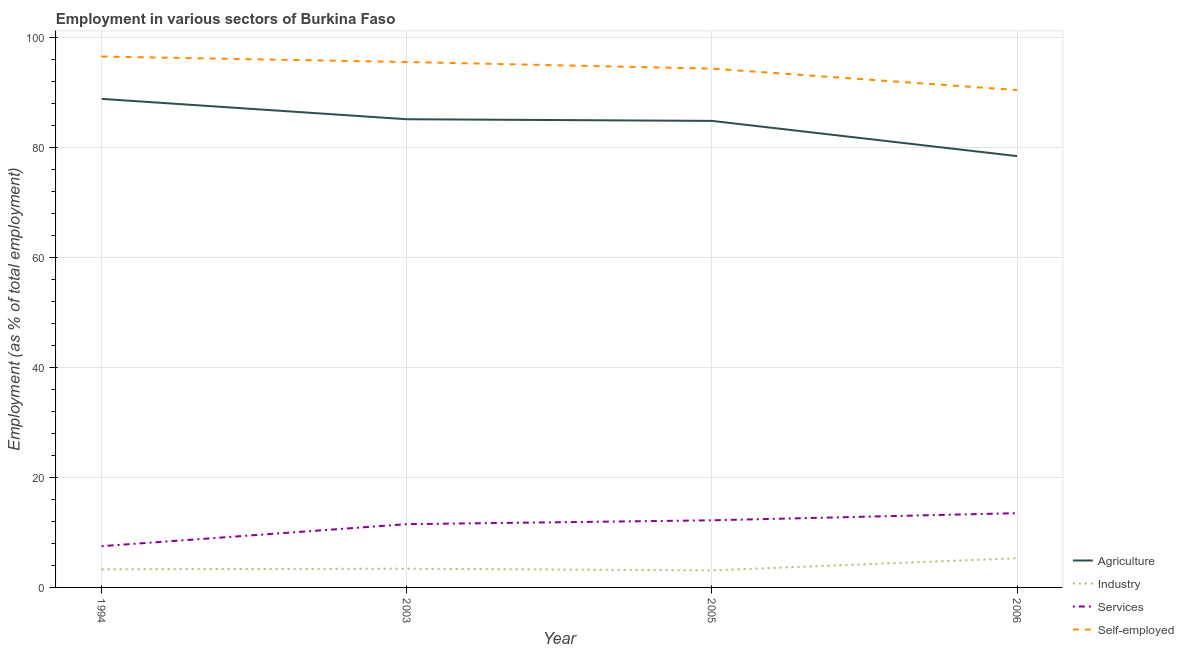Is the number of lines equal to the number of legend labels?
Your answer should be compact. Yes. What is the percentage of workers in services in 2005?
Provide a short and direct response. 12.2. Across all years, what is the maximum percentage of workers in agriculture?
Ensure brevity in your answer.  88.8. Across all years, what is the minimum percentage of self employed workers?
Provide a succinct answer. 90.4. In which year was the percentage of workers in services minimum?
Provide a succinct answer. 1994. What is the total percentage of workers in services in the graph?
Offer a very short reply. 44.7. What is the difference between the percentage of workers in industry in 2006 and the percentage of workers in services in 2005?
Provide a short and direct response. -6.9. What is the average percentage of self employed workers per year?
Give a very brief answer. 94.18. In the year 2003, what is the difference between the percentage of workers in services and percentage of workers in agriculture?
Provide a short and direct response. -73.6. In how many years, is the percentage of self employed workers greater than 64 %?
Make the answer very short. 4. What is the ratio of the percentage of workers in agriculture in 2005 to that in 2006?
Make the answer very short. 1.08. Is the difference between the percentage of workers in industry in 2005 and 2006 greater than the difference between the percentage of self employed workers in 2005 and 2006?
Your response must be concise. No. What is the difference between the highest and the second highest percentage of workers in services?
Give a very brief answer. 1.3. What is the difference between the highest and the lowest percentage of workers in industry?
Your response must be concise. 2.2. Does the percentage of workers in services monotonically increase over the years?
Your response must be concise. Yes. Is the percentage of workers in industry strictly less than the percentage of workers in services over the years?
Your response must be concise. Yes. How many years are there in the graph?
Your answer should be very brief. 4. Are the values on the major ticks of Y-axis written in scientific E-notation?
Provide a succinct answer. No. Does the graph contain any zero values?
Provide a short and direct response. No. How many legend labels are there?
Your response must be concise. 4. What is the title of the graph?
Your answer should be compact. Employment in various sectors of Burkina Faso. What is the label or title of the Y-axis?
Offer a very short reply. Employment (as % of total employment). What is the Employment (as % of total employment) in Agriculture in 1994?
Make the answer very short. 88.8. What is the Employment (as % of total employment) of Industry in 1994?
Your answer should be compact. 3.3. What is the Employment (as % of total employment) in Self-employed in 1994?
Ensure brevity in your answer.  96.5. What is the Employment (as % of total employment) in Agriculture in 2003?
Give a very brief answer. 85.1. What is the Employment (as % of total employment) of Industry in 2003?
Your answer should be compact. 3.4. What is the Employment (as % of total employment) of Services in 2003?
Provide a short and direct response. 11.5. What is the Employment (as % of total employment) of Self-employed in 2003?
Ensure brevity in your answer.  95.5. What is the Employment (as % of total employment) of Agriculture in 2005?
Your answer should be very brief. 84.8. What is the Employment (as % of total employment) of Industry in 2005?
Your answer should be very brief. 3.1. What is the Employment (as % of total employment) of Services in 2005?
Offer a very short reply. 12.2. What is the Employment (as % of total employment) of Self-employed in 2005?
Your answer should be very brief. 94.3. What is the Employment (as % of total employment) in Agriculture in 2006?
Give a very brief answer. 78.4. What is the Employment (as % of total employment) of Industry in 2006?
Give a very brief answer. 5.3. What is the Employment (as % of total employment) in Self-employed in 2006?
Offer a very short reply. 90.4. Across all years, what is the maximum Employment (as % of total employment) in Agriculture?
Make the answer very short. 88.8. Across all years, what is the maximum Employment (as % of total employment) in Industry?
Provide a short and direct response. 5.3. Across all years, what is the maximum Employment (as % of total employment) in Services?
Keep it short and to the point. 13.5. Across all years, what is the maximum Employment (as % of total employment) in Self-employed?
Your response must be concise. 96.5. Across all years, what is the minimum Employment (as % of total employment) of Agriculture?
Offer a very short reply. 78.4. Across all years, what is the minimum Employment (as % of total employment) of Industry?
Make the answer very short. 3.1. Across all years, what is the minimum Employment (as % of total employment) in Self-employed?
Provide a short and direct response. 90.4. What is the total Employment (as % of total employment) of Agriculture in the graph?
Make the answer very short. 337.1. What is the total Employment (as % of total employment) in Industry in the graph?
Offer a very short reply. 15.1. What is the total Employment (as % of total employment) in Services in the graph?
Keep it short and to the point. 44.7. What is the total Employment (as % of total employment) in Self-employed in the graph?
Ensure brevity in your answer.  376.7. What is the difference between the Employment (as % of total employment) in Agriculture in 1994 and that in 2003?
Your answer should be compact. 3.7. What is the difference between the Employment (as % of total employment) of Services in 1994 and that in 2003?
Provide a short and direct response. -4. What is the difference between the Employment (as % of total employment) in Self-employed in 1994 and that in 2003?
Provide a succinct answer. 1. What is the difference between the Employment (as % of total employment) in Agriculture in 1994 and that in 2005?
Your answer should be compact. 4. What is the difference between the Employment (as % of total employment) of Services in 1994 and that in 2005?
Make the answer very short. -4.7. What is the difference between the Employment (as % of total employment) of Services in 1994 and that in 2006?
Offer a terse response. -6. What is the difference between the Employment (as % of total employment) of Self-employed in 1994 and that in 2006?
Your answer should be compact. 6.1. What is the difference between the Employment (as % of total employment) in Services in 2003 and that in 2005?
Provide a short and direct response. -0.7. What is the difference between the Employment (as % of total employment) in Self-employed in 2003 and that in 2005?
Ensure brevity in your answer.  1.2. What is the difference between the Employment (as % of total employment) in Services in 2003 and that in 2006?
Your answer should be very brief. -2. What is the difference between the Employment (as % of total employment) in Agriculture in 2005 and that in 2006?
Offer a terse response. 6.4. What is the difference between the Employment (as % of total employment) of Services in 2005 and that in 2006?
Your answer should be very brief. -1.3. What is the difference between the Employment (as % of total employment) of Self-employed in 2005 and that in 2006?
Your answer should be compact. 3.9. What is the difference between the Employment (as % of total employment) in Agriculture in 1994 and the Employment (as % of total employment) in Industry in 2003?
Your answer should be very brief. 85.4. What is the difference between the Employment (as % of total employment) in Agriculture in 1994 and the Employment (as % of total employment) in Services in 2003?
Offer a very short reply. 77.3. What is the difference between the Employment (as % of total employment) in Industry in 1994 and the Employment (as % of total employment) in Services in 2003?
Provide a short and direct response. -8.2. What is the difference between the Employment (as % of total employment) in Industry in 1994 and the Employment (as % of total employment) in Self-employed in 2003?
Keep it short and to the point. -92.2. What is the difference between the Employment (as % of total employment) of Services in 1994 and the Employment (as % of total employment) of Self-employed in 2003?
Give a very brief answer. -88. What is the difference between the Employment (as % of total employment) in Agriculture in 1994 and the Employment (as % of total employment) in Industry in 2005?
Provide a short and direct response. 85.7. What is the difference between the Employment (as % of total employment) in Agriculture in 1994 and the Employment (as % of total employment) in Services in 2005?
Provide a succinct answer. 76.6. What is the difference between the Employment (as % of total employment) of Agriculture in 1994 and the Employment (as % of total employment) of Self-employed in 2005?
Ensure brevity in your answer.  -5.5. What is the difference between the Employment (as % of total employment) of Industry in 1994 and the Employment (as % of total employment) of Self-employed in 2005?
Your answer should be compact. -91. What is the difference between the Employment (as % of total employment) of Services in 1994 and the Employment (as % of total employment) of Self-employed in 2005?
Your answer should be compact. -86.8. What is the difference between the Employment (as % of total employment) in Agriculture in 1994 and the Employment (as % of total employment) in Industry in 2006?
Offer a terse response. 83.5. What is the difference between the Employment (as % of total employment) of Agriculture in 1994 and the Employment (as % of total employment) of Services in 2006?
Offer a very short reply. 75.3. What is the difference between the Employment (as % of total employment) in Agriculture in 1994 and the Employment (as % of total employment) in Self-employed in 2006?
Your response must be concise. -1.6. What is the difference between the Employment (as % of total employment) of Industry in 1994 and the Employment (as % of total employment) of Services in 2006?
Make the answer very short. -10.2. What is the difference between the Employment (as % of total employment) of Industry in 1994 and the Employment (as % of total employment) of Self-employed in 2006?
Your answer should be very brief. -87.1. What is the difference between the Employment (as % of total employment) in Services in 1994 and the Employment (as % of total employment) in Self-employed in 2006?
Your response must be concise. -82.9. What is the difference between the Employment (as % of total employment) of Agriculture in 2003 and the Employment (as % of total employment) of Services in 2005?
Your answer should be very brief. 72.9. What is the difference between the Employment (as % of total employment) of Agriculture in 2003 and the Employment (as % of total employment) of Self-employed in 2005?
Give a very brief answer. -9.2. What is the difference between the Employment (as % of total employment) in Industry in 2003 and the Employment (as % of total employment) in Services in 2005?
Make the answer very short. -8.8. What is the difference between the Employment (as % of total employment) of Industry in 2003 and the Employment (as % of total employment) of Self-employed in 2005?
Provide a short and direct response. -90.9. What is the difference between the Employment (as % of total employment) in Services in 2003 and the Employment (as % of total employment) in Self-employed in 2005?
Make the answer very short. -82.8. What is the difference between the Employment (as % of total employment) in Agriculture in 2003 and the Employment (as % of total employment) in Industry in 2006?
Offer a terse response. 79.8. What is the difference between the Employment (as % of total employment) of Agriculture in 2003 and the Employment (as % of total employment) of Services in 2006?
Your answer should be compact. 71.6. What is the difference between the Employment (as % of total employment) in Agriculture in 2003 and the Employment (as % of total employment) in Self-employed in 2006?
Give a very brief answer. -5.3. What is the difference between the Employment (as % of total employment) of Industry in 2003 and the Employment (as % of total employment) of Services in 2006?
Your answer should be compact. -10.1. What is the difference between the Employment (as % of total employment) in Industry in 2003 and the Employment (as % of total employment) in Self-employed in 2006?
Provide a short and direct response. -87. What is the difference between the Employment (as % of total employment) in Services in 2003 and the Employment (as % of total employment) in Self-employed in 2006?
Ensure brevity in your answer.  -78.9. What is the difference between the Employment (as % of total employment) in Agriculture in 2005 and the Employment (as % of total employment) in Industry in 2006?
Give a very brief answer. 79.5. What is the difference between the Employment (as % of total employment) of Agriculture in 2005 and the Employment (as % of total employment) of Services in 2006?
Your response must be concise. 71.3. What is the difference between the Employment (as % of total employment) in Agriculture in 2005 and the Employment (as % of total employment) in Self-employed in 2006?
Give a very brief answer. -5.6. What is the difference between the Employment (as % of total employment) of Industry in 2005 and the Employment (as % of total employment) of Services in 2006?
Keep it short and to the point. -10.4. What is the difference between the Employment (as % of total employment) of Industry in 2005 and the Employment (as % of total employment) of Self-employed in 2006?
Give a very brief answer. -87.3. What is the difference between the Employment (as % of total employment) in Services in 2005 and the Employment (as % of total employment) in Self-employed in 2006?
Your answer should be compact. -78.2. What is the average Employment (as % of total employment) in Agriculture per year?
Provide a short and direct response. 84.28. What is the average Employment (as % of total employment) of Industry per year?
Provide a short and direct response. 3.77. What is the average Employment (as % of total employment) of Services per year?
Provide a succinct answer. 11.18. What is the average Employment (as % of total employment) in Self-employed per year?
Your answer should be compact. 94.17. In the year 1994, what is the difference between the Employment (as % of total employment) in Agriculture and Employment (as % of total employment) in Industry?
Provide a succinct answer. 85.5. In the year 1994, what is the difference between the Employment (as % of total employment) of Agriculture and Employment (as % of total employment) of Services?
Keep it short and to the point. 81.3. In the year 1994, what is the difference between the Employment (as % of total employment) of Industry and Employment (as % of total employment) of Services?
Your answer should be very brief. -4.2. In the year 1994, what is the difference between the Employment (as % of total employment) of Industry and Employment (as % of total employment) of Self-employed?
Provide a succinct answer. -93.2. In the year 1994, what is the difference between the Employment (as % of total employment) in Services and Employment (as % of total employment) in Self-employed?
Keep it short and to the point. -89. In the year 2003, what is the difference between the Employment (as % of total employment) in Agriculture and Employment (as % of total employment) in Industry?
Give a very brief answer. 81.7. In the year 2003, what is the difference between the Employment (as % of total employment) of Agriculture and Employment (as % of total employment) of Services?
Give a very brief answer. 73.6. In the year 2003, what is the difference between the Employment (as % of total employment) in Agriculture and Employment (as % of total employment) in Self-employed?
Make the answer very short. -10.4. In the year 2003, what is the difference between the Employment (as % of total employment) of Industry and Employment (as % of total employment) of Services?
Ensure brevity in your answer.  -8.1. In the year 2003, what is the difference between the Employment (as % of total employment) of Industry and Employment (as % of total employment) of Self-employed?
Keep it short and to the point. -92.1. In the year 2003, what is the difference between the Employment (as % of total employment) in Services and Employment (as % of total employment) in Self-employed?
Your answer should be compact. -84. In the year 2005, what is the difference between the Employment (as % of total employment) of Agriculture and Employment (as % of total employment) of Industry?
Give a very brief answer. 81.7. In the year 2005, what is the difference between the Employment (as % of total employment) of Agriculture and Employment (as % of total employment) of Services?
Provide a succinct answer. 72.6. In the year 2005, what is the difference between the Employment (as % of total employment) of Agriculture and Employment (as % of total employment) of Self-employed?
Make the answer very short. -9.5. In the year 2005, what is the difference between the Employment (as % of total employment) of Industry and Employment (as % of total employment) of Services?
Your answer should be very brief. -9.1. In the year 2005, what is the difference between the Employment (as % of total employment) of Industry and Employment (as % of total employment) of Self-employed?
Make the answer very short. -91.2. In the year 2005, what is the difference between the Employment (as % of total employment) in Services and Employment (as % of total employment) in Self-employed?
Your response must be concise. -82.1. In the year 2006, what is the difference between the Employment (as % of total employment) in Agriculture and Employment (as % of total employment) in Industry?
Offer a very short reply. 73.1. In the year 2006, what is the difference between the Employment (as % of total employment) in Agriculture and Employment (as % of total employment) in Services?
Offer a terse response. 64.9. In the year 2006, what is the difference between the Employment (as % of total employment) of Agriculture and Employment (as % of total employment) of Self-employed?
Provide a short and direct response. -12. In the year 2006, what is the difference between the Employment (as % of total employment) in Industry and Employment (as % of total employment) in Services?
Offer a very short reply. -8.2. In the year 2006, what is the difference between the Employment (as % of total employment) in Industry and Employment (as % of total employment) in Self-employed?
Your answer should be compact. -85.1. In the year 2006, what is the difference between the Employment (as % of total employment) in Services and Employment (as % of total employment) in Self-employed?
Your answer should be compact. -76.9. What is the ratio of the Employment (as % of total employment) of Agriculture in 1994 to that in 2003?
Give a very brief answer. 1.04. What is the ratio of the Employment (as % of total employment) in Industry in 1994 to that in 2003?
Offer a very short reply. 0.97. What is the ratio of the Employment (as % of total employment) of Services in 1994 to that in 2003?
Your answer should be compact. 0.65. What is the ratio of the Employment (as % of total employment) of Self-employed in 1994 to that in 2003?
Your answer should be very brief. 1.01. What is the ratio of the Employment (as % of total employment) of Agriculture in 1994 to that in 2005?
Your response must be concise. 1.05. What is the ratio of the Employment (as % of total employment) in Industry in 1994 to that in 2005?
Keep it short and to the point. 1.06. What is the ratio of the Employment (as % of total employment) in Services in 1994 to that in 2005?
Ensure brevity in your answer.  0.61. What is the ratio of the Employment (as % of total employment) in Self-employed in 1994 to that in 2005?
Provide a succinct answer. 1.02. What is the ratio of the Employment (as % of total employment) in Agriculture in 1994 to that in 2006?
Your answer should be compact. 1.13. What is the ratio of the Employment (as % of total employment) in Industry in 1994 to that in 2006?
Your answer should be very brief. 0.62. What is the ratio of the Employment (as % of total employment) in Services in 1994 to that in 2006?
Give a very brief answer. 0.56. What is the ratio of the Employment (as % of total employment) of Self-employed in 1994 to that in 2006?
Keep it short and to the point. 1.07. What is the ratio of the Employment (as % of total employment) of Agriculture in 2003 to that in 2005?
Your answer should be compact. 1. What is the ratio of the Employment (as % of total employment) in Industry in 2003 to that in 2005?
Offer a terse response. 1.1. What is the ratio of the Employment (as % of total employment) in Services in 2003 to that in 2005?
Your answer should be compact. 0.94. What is the ratio of the Employment (as % of total employment) of Self-employed in 2003 to that in 2005?
Provide a short and direct response. 1.01. What is the ratio of the Employment (as % of total employment) of Agriculture in 2003 to that in 2006?
Provide a short and direct response. 1.09. What is the ratio of the Employment (as % of total employment) of Industry in 2003 to that in 2006?
Give a very brief answer. 0.64. What is the ratio of the Employment (as % of total employment) in Services in 2003 to that in 2006?
Your answer should be very brief. 0.85. What is the ratio of the Employment (as % of total employment) of Self-employed in 2003 to that in 2006?
Make the answer very short. 1.06. What is the ratio of the Employment (as % of total employment) in Agriculture in 2005 to that in 2006?
Your response must be concise. 1.08. What is the ratio of the Employment (as % of total employment) of Industry in 2005 to that in 2006?
Make the answer very short. 0.58. What is the ratio of the Employment (as % of total employment) of Services in 2005 to that in 2006?
Offer a terse response. 0.9. What is the ratio of the Employment (as % of total employment) in Self-employed in 2005 to that in 2006?
Give a very brief answer. 1.04. What is the difference between the highest and the second highest Employment (as % of total employment) in Agriculture?
Give a very brief answer. 3.7. What is the difference between the highest and the second highest Employment (as % of total employment) of Industry?
Give a very brief answer. 1.9. What is the difference between the highest and the second highest Employment (as % of total employment) of Services?
Your answer should be compact. 1.3. What is the difference between the highest and the second highest Employment (as % of total employment) of Self-employed?
Keep it short and to the point. 1. What is the difference between the highest and the lowest Employment (as % of total employment) in Industry?
Keep it short and to the point. 2.2. 